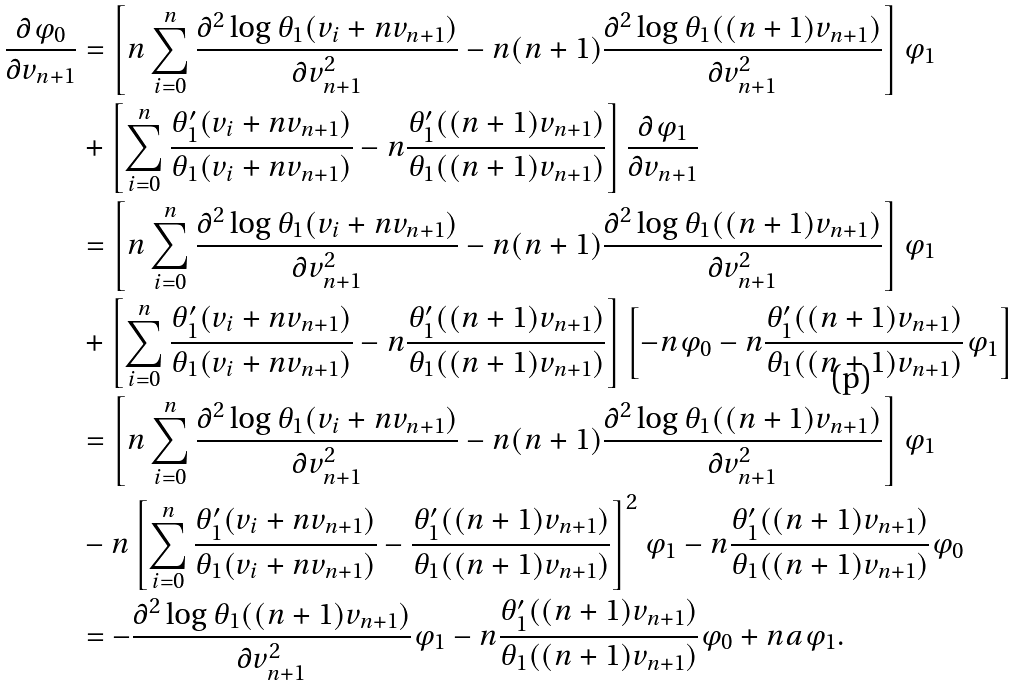Convert formula to latex. <formula><loc_0><loc_0><loc_500><loc_500>\frac { \partial \varphi _ { 0 } } { \partial v _ { n + 1 } } & = \left [ n \sum _ { i = 0 } ^ { n } \frac { \partial ^ { 2 } \log \theta _ { 1 } ( v _ { i } + n v _ { n + 1 } ) } { \partial v _ { n + 1 } ^ { 2 } } - n ( n + 1 ) \frac { \partial ^ { 2 } \log \theta _ { 1 } ( ( n + 1 ) v _ { n + 1 } ) } { \partial v _ { n + 1 } ^ { 2 } } \right ] \varphi _ { 1 } \\ & + \left [ \sum _ { i = 0 } ^ { n } \frac { \theta _ { 1 } ^ { \prime } ( v _ { i } + n v _ { n + 1 } ) } { \theta _ { 1 } ( v _ { i } + n v _ { n + 1 } ) } - n \frac { \theta _ { 1 } ^ { \prime } ( ( n + 1 ) v _ { n + 1 } ) } { \theta _ { 1 } ( ( n + 1 ) v _ { n + 1 } ) } \right ] \frac { \partial \varphi _ { 1 } } { \partial v _ { n + 1 } } \\ & = \left [ n \sum _ { i = 0 } ^ { n } \frac { \partial ^ { 2 } \log \theta _ { 1 } ( v _ { i } + n v _ { n + 1 } ) } { \partial v _ { n + 1 } ^ { 2 } } - n ( n + 1 ) \frac { \partial ^ { 2 } \log \theta _ { 1 } ( ( n + 1 ) v _ { n + 1 } ) } { \partial v _ { n + 1 } ^ { 2 } } \right ] \varphi _ { 1 } \\ & + \left [ \sum _ { i = 0 } ^ { n } \frac { \theta _ { 1 } ^ { \prime } ( v _ { i } + n v _ { n + 1 } ) } { \theta _ { 1 } ( v _ { i } + n v _ { n + 1 } ) } - n \frac { \theta _ { 1 } ^ { \prime } ( ( n + 1 ) v _ { n + 1 } ) } { \theta _ { 1 } ( ( n + 1 ) v _ { n + 1 } ) } \right ] \left [ - n \varphi _ { 0 } - n \frac { \theta _ { 1 } ^ { \prime } ( ( n + 1 ) v _ { n + 1 } ) } { \theta _ { 1 } ( ( n + 1 ) v _ { n + 1 } ) } \varphi _ { 1 } \right ] \\ & = \left [ n \sum _ { i = 0 } ^ { n } \frac { \partial ^ { 2 } \log \theta _ { 1 } ( v _ { i } + n v _ { n + 1 } ) } { \partial v _ { n + 1 } ^ { 2 } } - n ( n + 1 ) \frac { \partial ^ { 2 } \log \theta _ { 1 } ( ( n + 1 ) v _ { n + 1 } ) } { \partial v _ { n + 1 } ^ { 2 } } \right ] \varphi _ { 1 } \\ & - n \left [ \sum _ { i = 0 } ^ { n } \frac { \theta _ { 1 } ^ { \prime } ( v _ { i } + n v _ { n + 1 } ) } { \theta _ { 1 } ( v _ { i } + n v _ { n + 1 } ) } - \frac { \theta _ { 1 } ^ { \prime } ( ( n + 1 ) v _ { n + 1 } ) } { \theta _ { 1 } ( ( n + 1 ) v _ { n + 1 } ) } \right ] ^ { 2 } \varphi _ { 1 } - n \frac { \theta _ { 1 } ^ { \prime } ( ( n + 1 ) v _ { n + 1 } ) } { \theta _ { 1 } ( ( n + 1 ) v _ { n + 1 } ) } \varphi _ { 0 } \\ & = - \frac { \partial ^ { 2 } \log \theta _ { 1 } ( ( n + 1 ) v _ { n + 1 } ) } { \partial v _ { n + 1 } ^ { 2 } } \varphi _ { 1 } - n \frac { \theta _ { 1 } ^ { \prime } ( ( n + 1 ) v _ { n + 1 } ) } { \theta _ { 1 } ( ( n + 1 ) v _ { n + 1 } ) } \varphi _ { 0 } + n a \varphi _ { 1 } . \\</formula> 